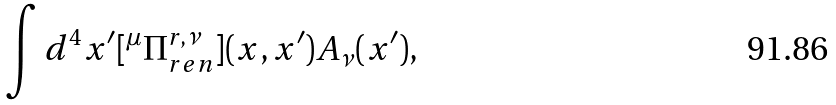Convert formula to latex. <formula><loc_0><loc_0><loc_500><loc_500>\int d ^ { 4 } x ^ { \prime } [ ^ { \mu } \Pi ^ { r , \nu } _ { r e n } ] ( x , x ^ { \prime } ) A _ { \nu } ( x ^ { \prime } ) ,</formula> 